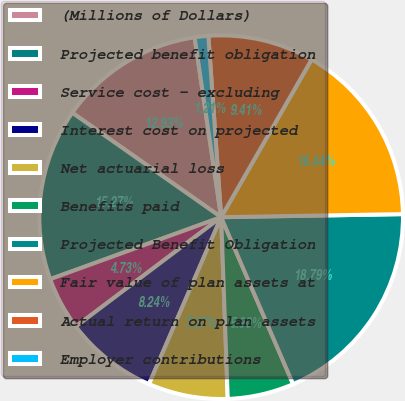Convert chart. <chart><loc_0><loc_0><loc_500><loc_500><pie_chart><fcel>(Millions of Dollars)<fcel>Projected benefit obligation<fcel>Service cost - excluding<fcel>Interest cost on projected<fcel>Net actuarial loss<fcel>Benefits paid<fcel>Projected Benefit Obligation<fcel>Fair value of plan assets at<fcel>Actual return on plan assets<fcel>Employer contributions<nl><fcel>12.93%<fcel>15.27%<fcel>4.73%<fcel>8.24%<fcel>7.07%<fcel>5.9%<fcel>18.79%<fcel>16.44%<fcel>9.41%<fcel>1.21%<nl></chart> 